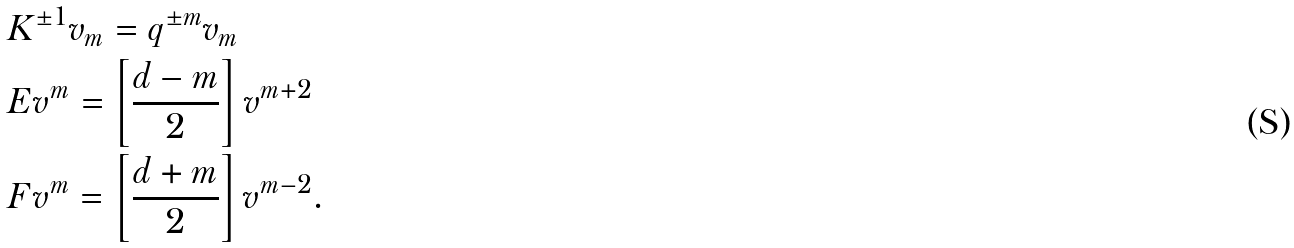Convert formula to latex. <formula><loc_0><loc_0><loc_500><loc_500>& K ^ { \pm 1 } v _ { m } = q ^ { \pm m } v _ { m } \\ & E v ^ { m } = \left [ \frac { d - m } { 2 } \right ] v ^ { m + 2 } \\ & F v ^ { m } = \left [ \frac { d + m } { 2 } \right ] v ^ { m - 2 } .</formula> 